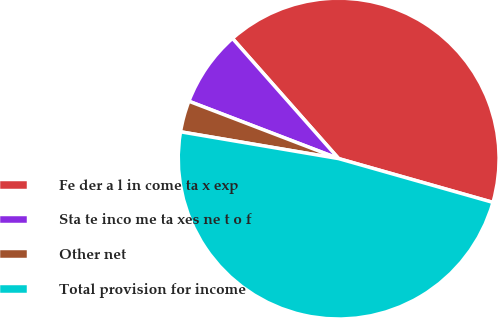<chart> <loc_0><loc_0><loc_500><loc_500><pie_chart><fcel>Fe der a l in come ta x exp<fcel>Sta te inco me ta xes ne t o f<fcel>Other net<fcel>Total provision for income<nl><fcel>40.92%<fcel>7.66%<fcel>3.15%<fcel>48.27%<nl></chart> 